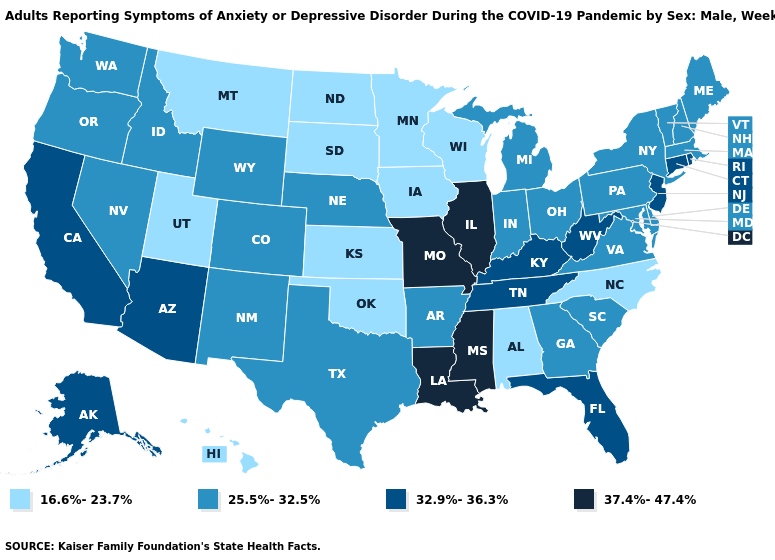Which states hav the highest value in the South?
Keep it brief. Louisiana, Mississippi. Which states have the lowest value in the West?
Short answer required. Hawaii, Montana, Utah. Does Louisiana have the highest value in the USA?
Keep it brief. Yes. Is the legend a continuous bar?
Answer briefly. No. Does Illinois have the highest value in the MidWest?
Write a very short answer. Yes. Name the states that have a value in the range 32.9%-36.3%?
Write a very short answer. Alaska, Arizona, California, Connecticut, Florida, Kentucky, New Jersey, Rhode Island, Tennessee, West Virginia. What is the value of Nevada?
Answer briefly. 25.5%-32.5%. Does Tennessee have a lower value than Minnesota?
Answer briefly. No. Which states hav the highest value in the Northeast?
Be succinct. Connecticut, New Jersey, Rhode Island. What is the lowest value in the USA?
Answer briefly. 16.6%-23.7%. Name the states that have a value in the range 25.5%-32.5%?
Quick response, please. Arkansas, Colorado, Delaware, Georgia, Idaho, Indiana, Maine, Maryland, Massachusetts, Michigan, Nebraska, Nevada, New Hampshire, New Mexico, New York, Ohio, Oregon, Pennsylvania, South Carolina, Texas, Vermont, Virginia, Washington, Wyoming. What is the highest value in the USA?
Be succinct. 37.4%-47.4%. Name the states that have a value in the range 37.4%-47.4%?
Concise answer only. Illinois, Louisiana, Mississippi, Missouri. Among the states that border Maryland , does Virginia have the lowest value?
Keep it brief. Yes. Name the states that have a value in the range 37.4%-47.4%?
Give a very brief answer. Illinois, Louisiana, Mississippi, Missouri. 